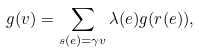Convert formula to latex. <formula><loc_0><loc_0><loc_500><loc_500>g ( v ) = \sum _ { s ( e ) = \gamma v } \lambda ( e ) g ( r ( e ) ) ,</formula> 